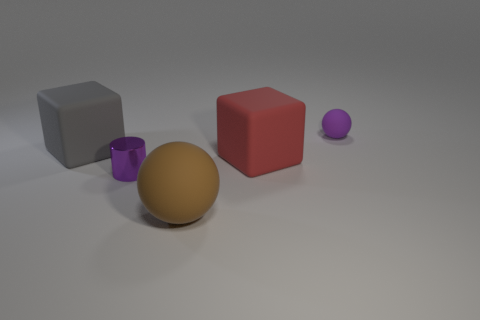Add 2 shiny things. How many objects exist? 7 Subtract all blocks. How many objects are left? 3 Subtract all big purple rubber cubes. Subtract all matte cubes. How many objects are left? 3 Add 5 small cylinders. How many small cylinders are left? 6 Add 3 matte objects. How many matte objects exist? 7 Subtract 0 cyan blocks. How many objects are left? 5 